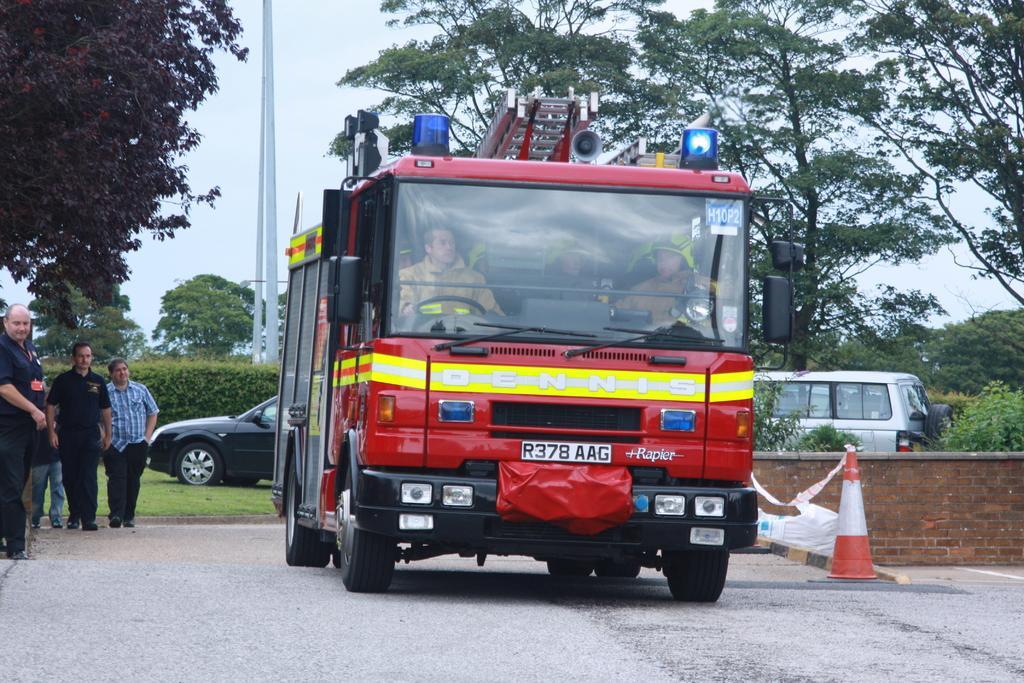How would you summarize this image in a sentence or two? In this picture we can see vehicles, people and a traffic cone on the ground and in the background we can see plants, trees, poles and the sky. 